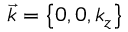Convert formula to latex. <formula><loc_0><loc_0><loc_500><loc_500>\vec { k } = \left \{ 0 , 0 , k _ { z } \right \}</formula> 